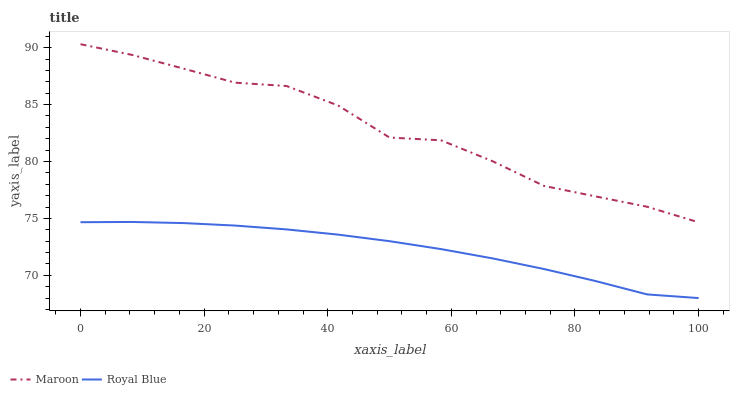Does Royal Blue have the minimum area under the curve?
Answer yes or no. Yes. Does Maroon have the maximum area under the curve?
Answer yes or no. Yes. Does Maroon have the minimum area under the curve?
Answer yes or no. No. Is Royal Blue the smoothest?
Answer yes or no. Yes. Is Maroon the roughest?
Answer yes or no. Yes. Is Maroon the smoothest?
Answer yes or no. No. Does Royal Blue have the lowest value?
Answer yes or no. Yes. Does Maroon have the lowest value?
Answer yes or no. No. Does Maroon have the highest value?
Answer yes or no. Yes. Is Royal Blue less than Maroon?
Answer yes or no. Yes. Is Maroon greater than Royal Blue?
Answer yes or no. Yes. Does Royal Blue intersect Maroon?
Answer yes or no. No. 